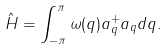<formula> <loc_0><loc_0><loc_500><loc_500>\hat { H } = \int _ { - \pi } ^ { \pi } \omega ( q ) a ^ { + } _ { q } a _ { q } d q .</formula> 